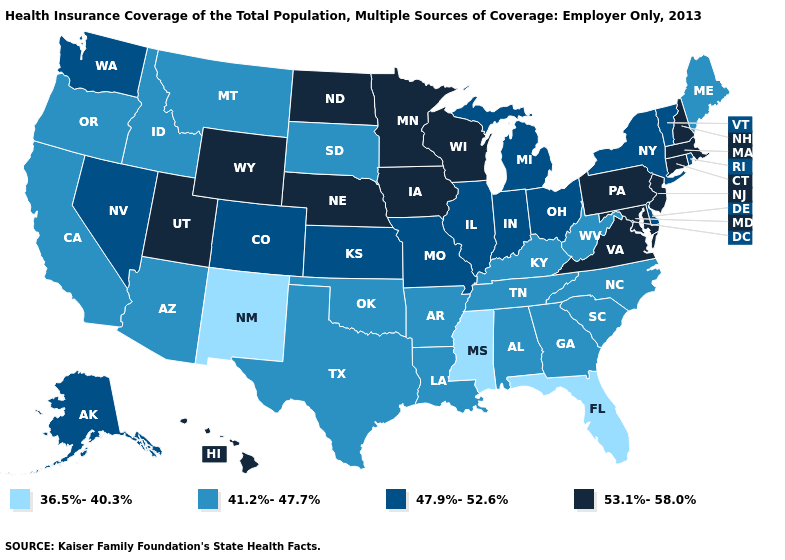Which states hav the highest value in the West?
Be succinct. Hawaii, Utah, Wyoming. Which states have the lowest value in the MidWest?
Give a very brief answer. South Dakota. What is the value of Idaho?
Concise answer only. 41.2%-47.7%. What is the highest value in the USA?
Give a very brief answer. 53.1%-58.0%. Which states have the highest value in the USA?
Answer briefly. Connecticut, Hawaii, Iowa, Maryland, Massachusetts, Minnesota, Nebraska, New Hampshire, New Jersey, North Dakota, Pennsylvania, Utah, Virginia, Wisconsin, Wyoming. What is the value of Idaho?
Give a very brief answer. 41.2%-47.7%. Name the states that have a value in the range 53.1%-58.0%?
Give a very brief answer. Connecticut, Hawaii, Iowa, Maryland, Massachusetts, Minnesota, Nebraska, New Hampshire, New Jersey, North Dakota, Pennsylvania, Utah, Virginia, Wisconsin, Wyoming. What is the value of Illinois?
Keep it brief. 47.9%-52.6%. Name the states that have a value in the range 41.2%-47.7%?
Give a very brief answer. Alabama, Arizona, Arkansas, California, Georgia, Idaho, Kentucky, Louisiana, Maine, Montana, North Carolina, Oklahoma, Oregon, South Carolina, South Dakota, Tennessee, Texas, West Virginia. Is the legend a continuous bar?
Keep it brief. No. Among the states that border Arizona , does California have the lowest value?
Keep it brief. No. Among the states that border Tennessee , which have the lowest value?
Be succinct. Mississippi. Does Nebraska have the same value as Vermont?
Write a very short answer. No. 